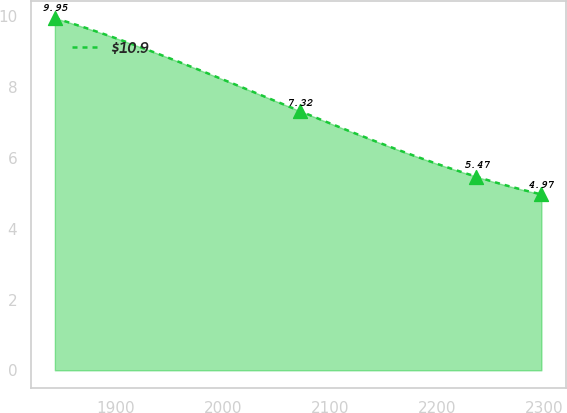Convert chart to OTSL. <chart><loc_0><loc_0><loc_500><loc_500><line_chart><ecel><fcel>$10.9<nl><fcel>1843.26<fcel>9.95<nl><fcel>2072.17<fcel>7.32<nl><fcel>2236.59<fcel>5.47<nl><fcel>2297.22<fcel>4.97<nl></chart> 